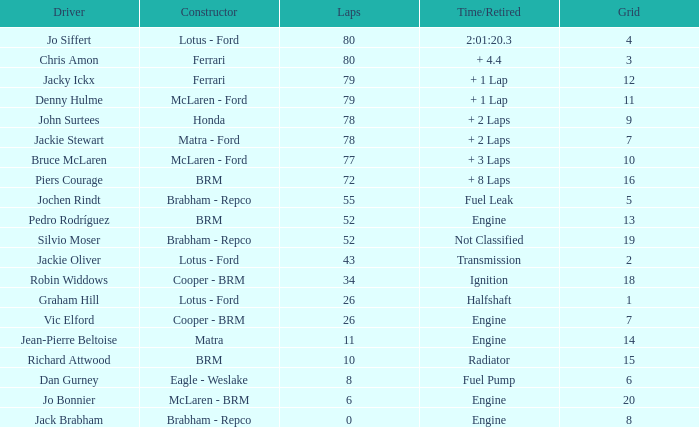What driver has a grid greater than 19? Jo Bonnier. 